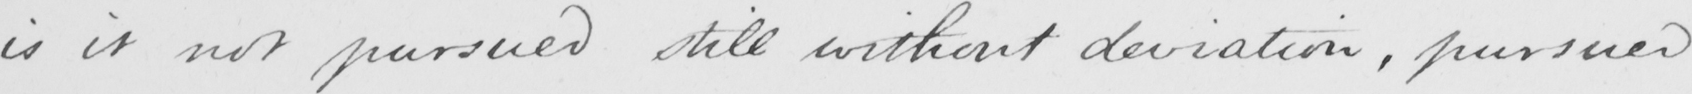Can you tell me what this handwritten text says? is it not pursued still without deviation , pursued 